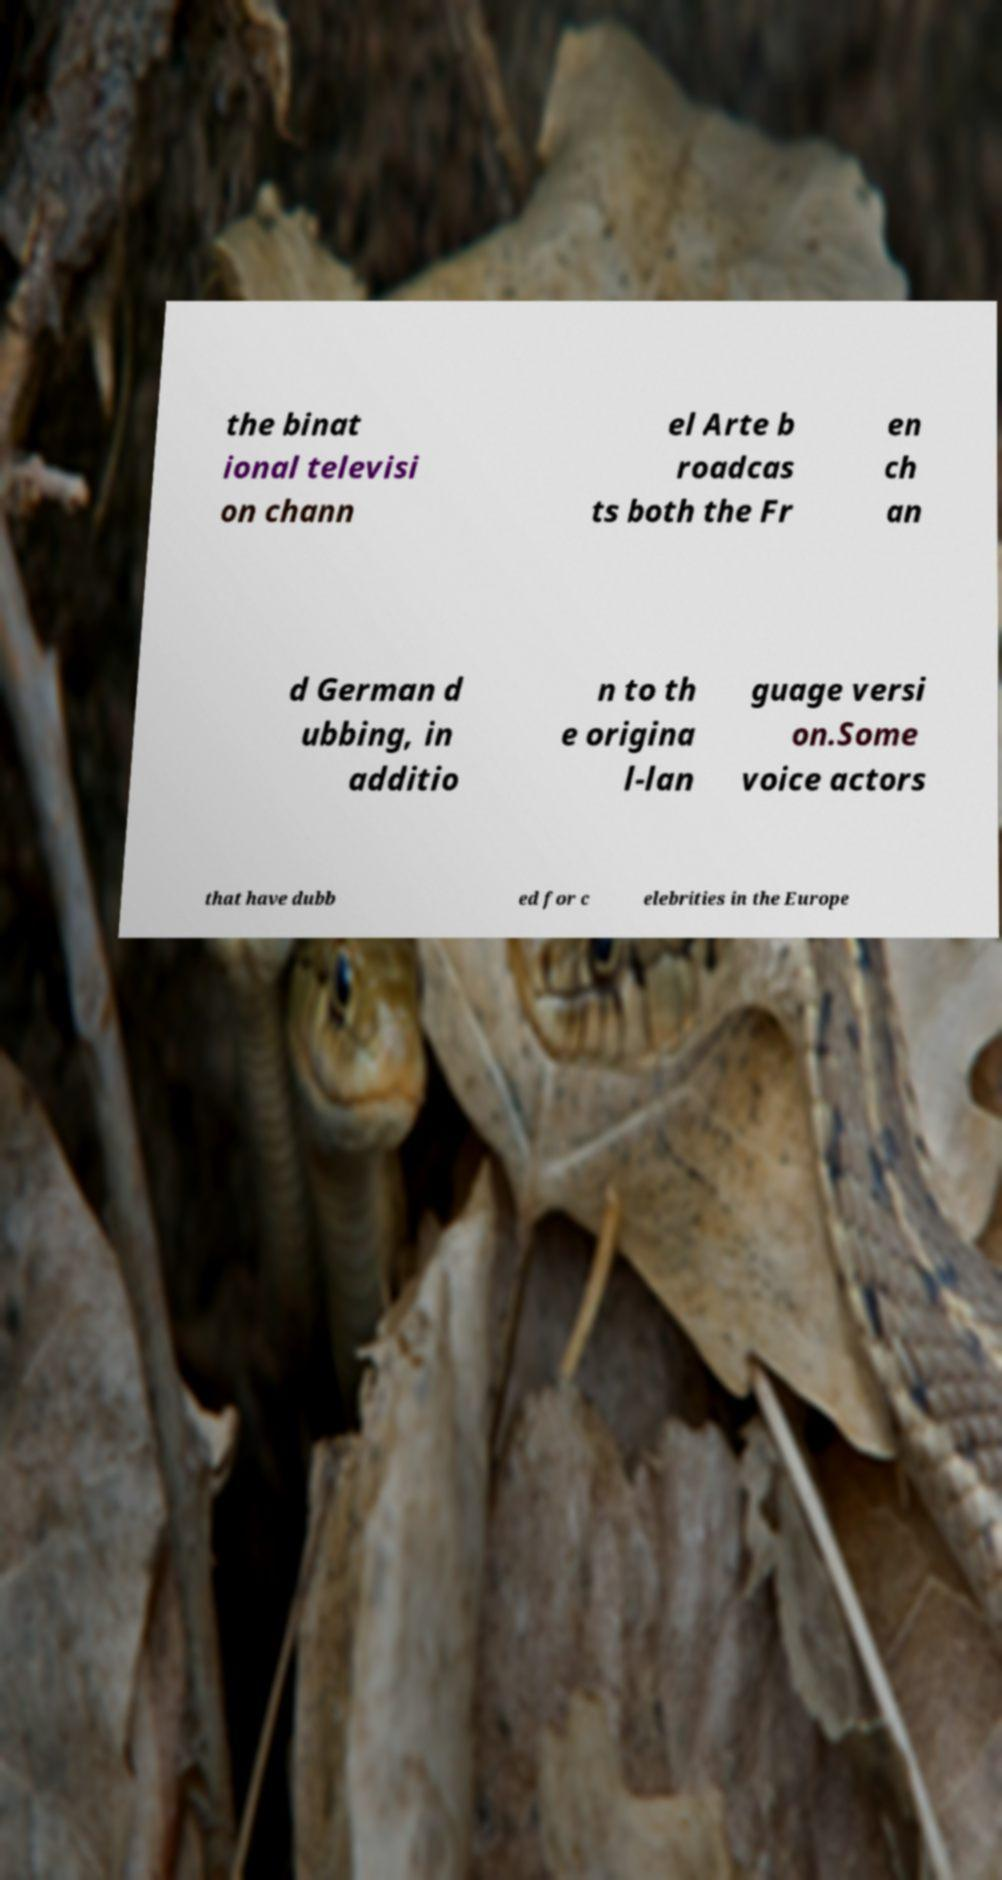What messages or text are displayed in this image? I need them in a readable, typed format. the binat ional televisi on chann el Arte b roadcas ts both the Fr en ch an d German d ubbing, in additio n to th e origina l-lan guage versi on.Some voice actors that have dubb ed for c elebrities in the Europe 